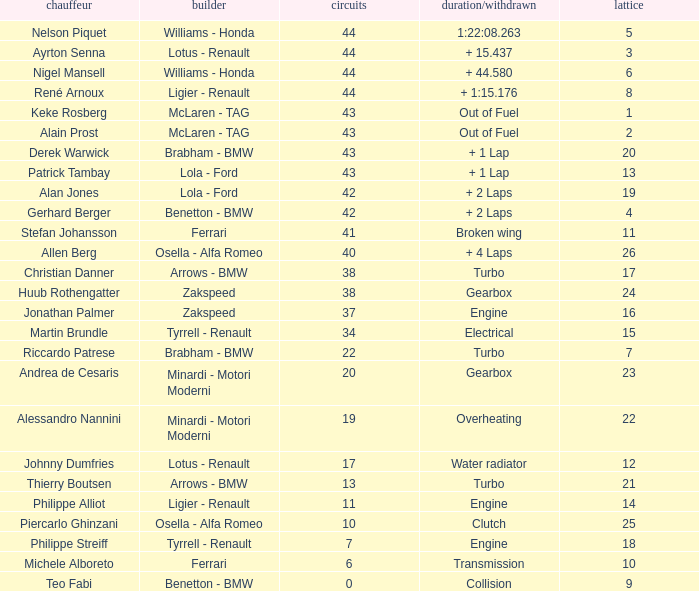I want the driver that has Laps of 10 Piercarlo Ghinzani. 